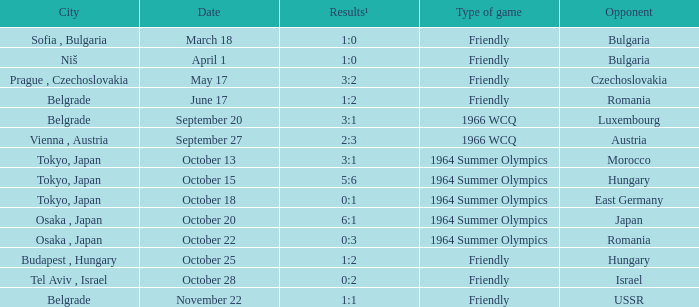Wjich city had a date of october 13? Tokyo, Japan. 